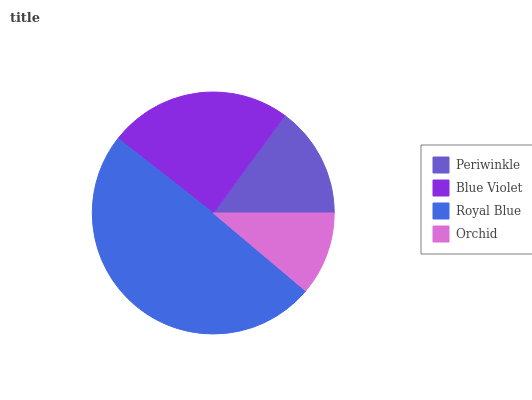Is Orchid the minimum?
Answer yes or no. Yes. Is Royal Blue the maximum?
Answer yes or no. Yes. Is Blue Violet the minimum?
Answer yes or no. No. Is Blue Violet the maximum?
Answer yes or no. No. Is Blue Violet greater than Periwinkle?
Answer yes or no. Yes. Is Periwinkle less than Blue Violet?
Answer yes or no. Yes. Is Periwinkle greater than Blue Violet?
Answer yes or no. No. Is Blue Violet less than Periwinkle?
Answer yes or no. No. Is Blue Violet the high median?
Answer yes or no. Yes. Is Periwinkle the low median?
Answer yes or no. Yes. Is Royal Blue the high median?
Answer yes or no. No. Is Royal Blue the low median?
Answer yes or no. No. 